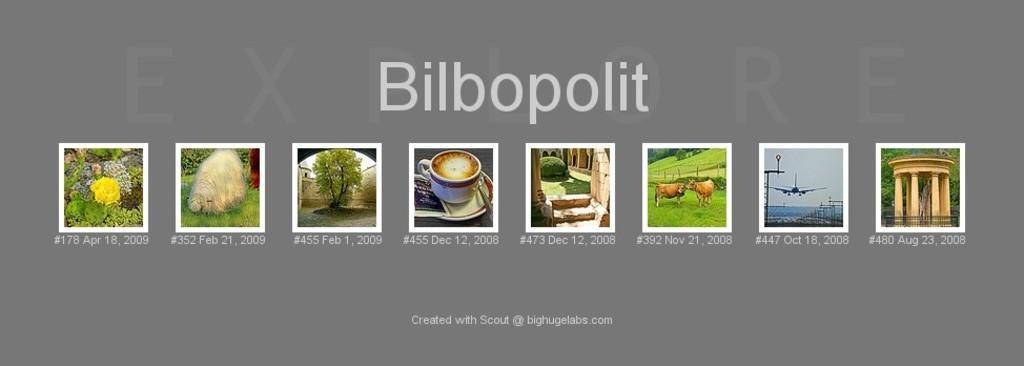Please provide a concise description of this image. In this picture, it is looking like a poster and on the poster there are different pictures like trees, flowers, a cup with a saucer, airplane and an architecture. 